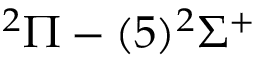Convert formula to latex. <formula><loc_0><loc_0><loc_500><loc_500>^ { 2 } \Pi - ( 5 ) ^ { 2 } \Sigma ^ { + }</formula> 